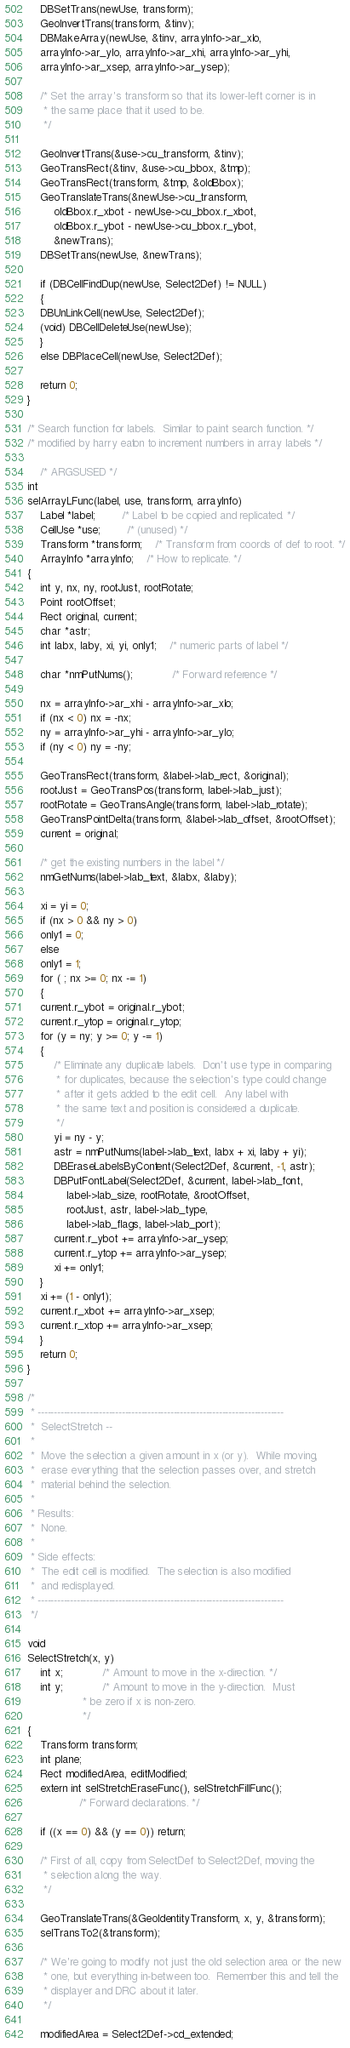<code> <loc_0><loc_0><loc_500><loc_500><_C_>
    DBSetTrans(newUse, transform);
    GeoInvertTrans(transform, &tinv);
    DBMakeArray(newUse, &tinv, arrayInfo->ar_xlo,
	arrayInfo->ar_ylo, arrayInfo->ar_xhi, arrayInfo->ar_yhi,
	arrayInfo->ar_xsep, arrayInfo->ar_ysep);

    /* Set the array's transform so that its lower-left corner is in
     * the same place that it used to be.
     */

    GeoInvertTrans(&use->cu_transform, &tinv);
    GeoTransRect(&tinv, &use->cu_bbox, &tmp);
    GeoTransRect(transform, &tmp, &oldBbox);
    GeoTranslateTrans(&newUse->cu_transform,
	    oldBbox.r_xbot - newUse->cu_bbox.r_xbot,
	    oldBbox.r_ybot - newUse->cu_bbox.r_ybot,
	    &newTrans);
    DBSetTrans(newUse, &newTrans);

    if (DBCellFindDup(newUse, Select2Def) != NULL)
    {
	DBUnLinkCell(newUse, Select2Def);
	(void) DBCellDeleteUse(newUse);
    }
    else DBPlaceCell(newUse, Select2Def);

    return 0;
}

/* Search function for labels.  Similar to paint search function. */
/* modified by harry eaton to increment numbers in array labels */

    /* ARGSUSED */
int
selArrayLFunc(label, use, transform, arrayInfo)
    Label *label;		/* Label to be copied and replicated. */
    CellUse *use;		/* (unused) */
    Transform *transform;	/* Transform from coords of def to root. */
    ArrayInfo *arrayInfo;	/* How to replicate. */
{
    int y, nx, ny, rootJust, rootRotate;
    Point rootOffset;
    Rect original, current;
    char *astr;
    int labx, laby, xi, yi, only1;	/* numeric parts of label */

    char *nmPutNums();			/* Forward reference */

    nx = arrayInfo->ar_xhi - arrayInfo->ar_xlo;
    if (nx < 0) nx = -nx;
    ny = arrayInfo->ar_yhi - arrayInfo->ar_ylo;
    if (ny < 0) ny = -ny;

    GeoTransRect(transform, &label->lab_rect, &original);
    rootJust = GeoTransPos(transform, label->lab_just);
    rootRotate = GeoTransAngle(transform, label->lab_rotate);
    GeoTransPointDelta(transform, &label->lab_offset, &rootOffset);
    current = original;

    /* get the existing numbers in the label */
    nmGetNums(label->lab_text, &labx, &laby);

    xi = yi = 0;
    if (nx > 0 && ny > 0)
	only1 = 0;
    else
	only1 = 1;
    for ( ; nx >= 0; nx -= 1)
    {
	current.r_ybot = original.r_ybot;
	current.r_ytop = original.r_ytop;
	for (y = ny; y >= 0; y -= 1)
	{
	    /* Eliminate any duplicate labels.  Don't use type in comparing
	     * for duplicates, because the selection's type could change
	     * after it gets added to the edit cell.  Any label with
	     * the same text and position is considered a duplicate.
	     */
	    yi = ny - y;
	    astr = nmPutNums(label->lab_text, labx + xi, laby + yi);
	    DBEraseLabelsByContent(Select2Def, &current, -1, astr);
	    DBPutFontLabel(Select2Def, &current, label->lab_font,
			label->lab_size, rootRotate, &rootOffset,
			rootJust, astr, label->lab_type,
			label->lab_flags, label->lab_port);
	    current.r_ybot += arrayInfo->ar_ysep;
	    current.r_ytop += arrayInfo->ar_ysep;
	    xi += only1;
	}
	xi += (1 - only1);
	current.r_xbot += arrayInfo->ar_xsep;
	current.r_xtop += arrayInfo->ar_xsep;
    }
    return 0;
}

/*
 * ----------------------------------------------------------------------------
 *	SelectStretch --
 *
 * 	Move the selection a given amount in x (or y).  While moving,
 *	erase everything that the selection passes over, and stretch
 *	material behind the selection.
 *
 * Results:
 *	None.
 *
 * Side effects:
 *	The edit cell is modified.  The selection is also modified
 *	and redisplayed.
 * ----------------------------------------------------------------------------
 */

void
SelectStretch(x, y)
    int x;			/* Amount to move in the x-direction. */
    int y;			/* Amount to move in the y-direction.  Must
				 * be zero if x is non-zero.
				 */
{
    Transform transform;
    int plane;
    Rect modifiedArea, editModified;
    extern int selStretchEraseFunc(), selStretchFillFunc();
				/* Forward declarations. */

    if ((x == 0) && (y == 0)) return;

    /* First of all, copy from SelectDef to Select2Def, moving the
     * selection along the way.
     */

    GeoTranslateTrans(&GeoIdentityTransform, x, y, &transform);
    selTransTo2(&transform);

    /* We're going to modify not just the old selection area or the new
     * one, but everything in-between too.  Remember this and tell the
     * displayer and DRC about it later.
     */

    modifiedArea = Select2Def->cd_extended;</code> 